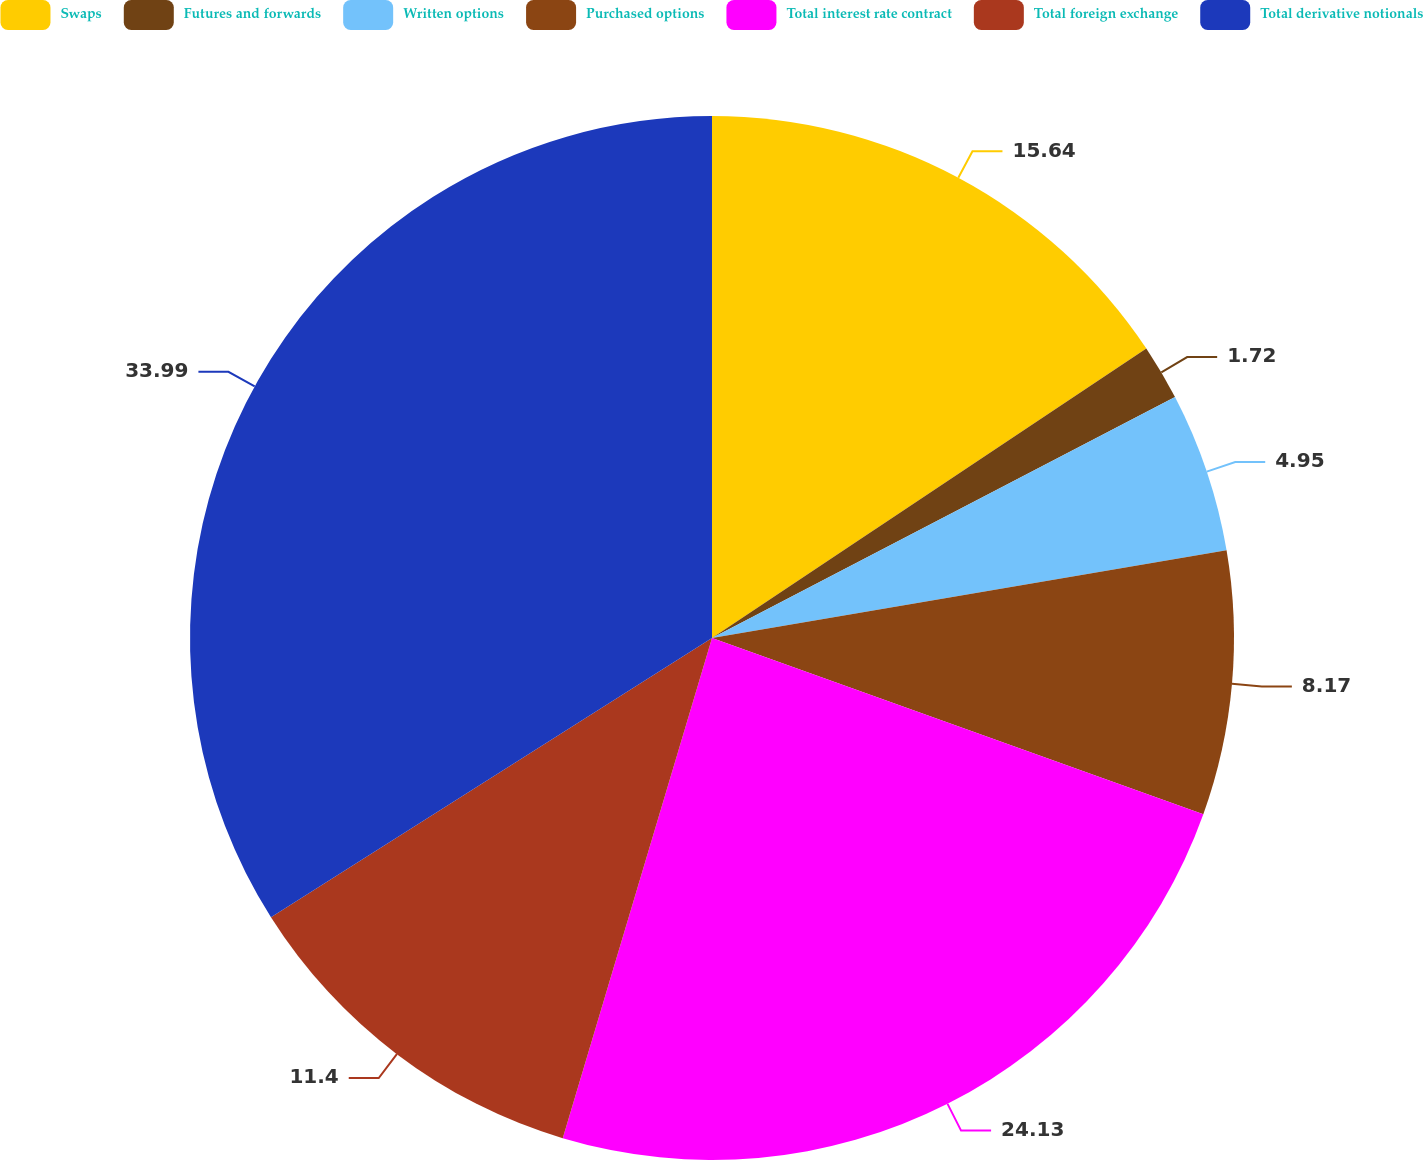Convert chart to OTSL. <chart><loc_0><loc_0><loc_500><loc_500><pie_chart><fcel>Swaps<fcel>Futures and forwards<fcel>Written options<fcel>Purchased options<fcel>Total interest rate contract<fcel>Total foreign exchange<fcel>Total derivative notionals<nl><fcel>15.64%<fcel>1.72%<fcel>4.95%<fcel>8.17%<fcel>24.13%<fcel>11.4%<fcel>33.98%<nl></chart> 